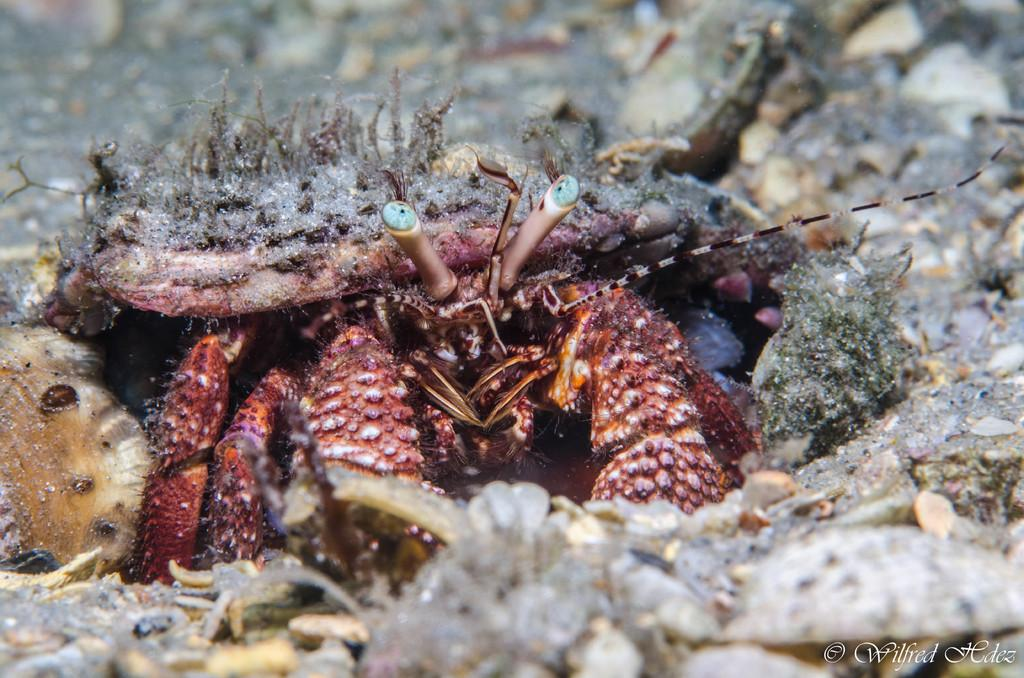What type of animal is in the middle of the image? There is a reptile in the middle of the image. What can be seen in the background of the image? There is a land with stones in the background of the image. What type of support can be seen in the image? There is no specific support visible in the image; it features a reptile and a land with stones in the background. 